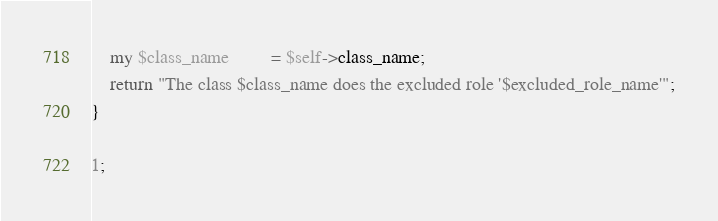<code> <loc_0><loc_0><loc_500><loc_500><_Perl_>    my $class_name         = $self->class_name;
    return "The class $class_name does the excluded role '$excluded_role_name'";
}

1;
</code> 